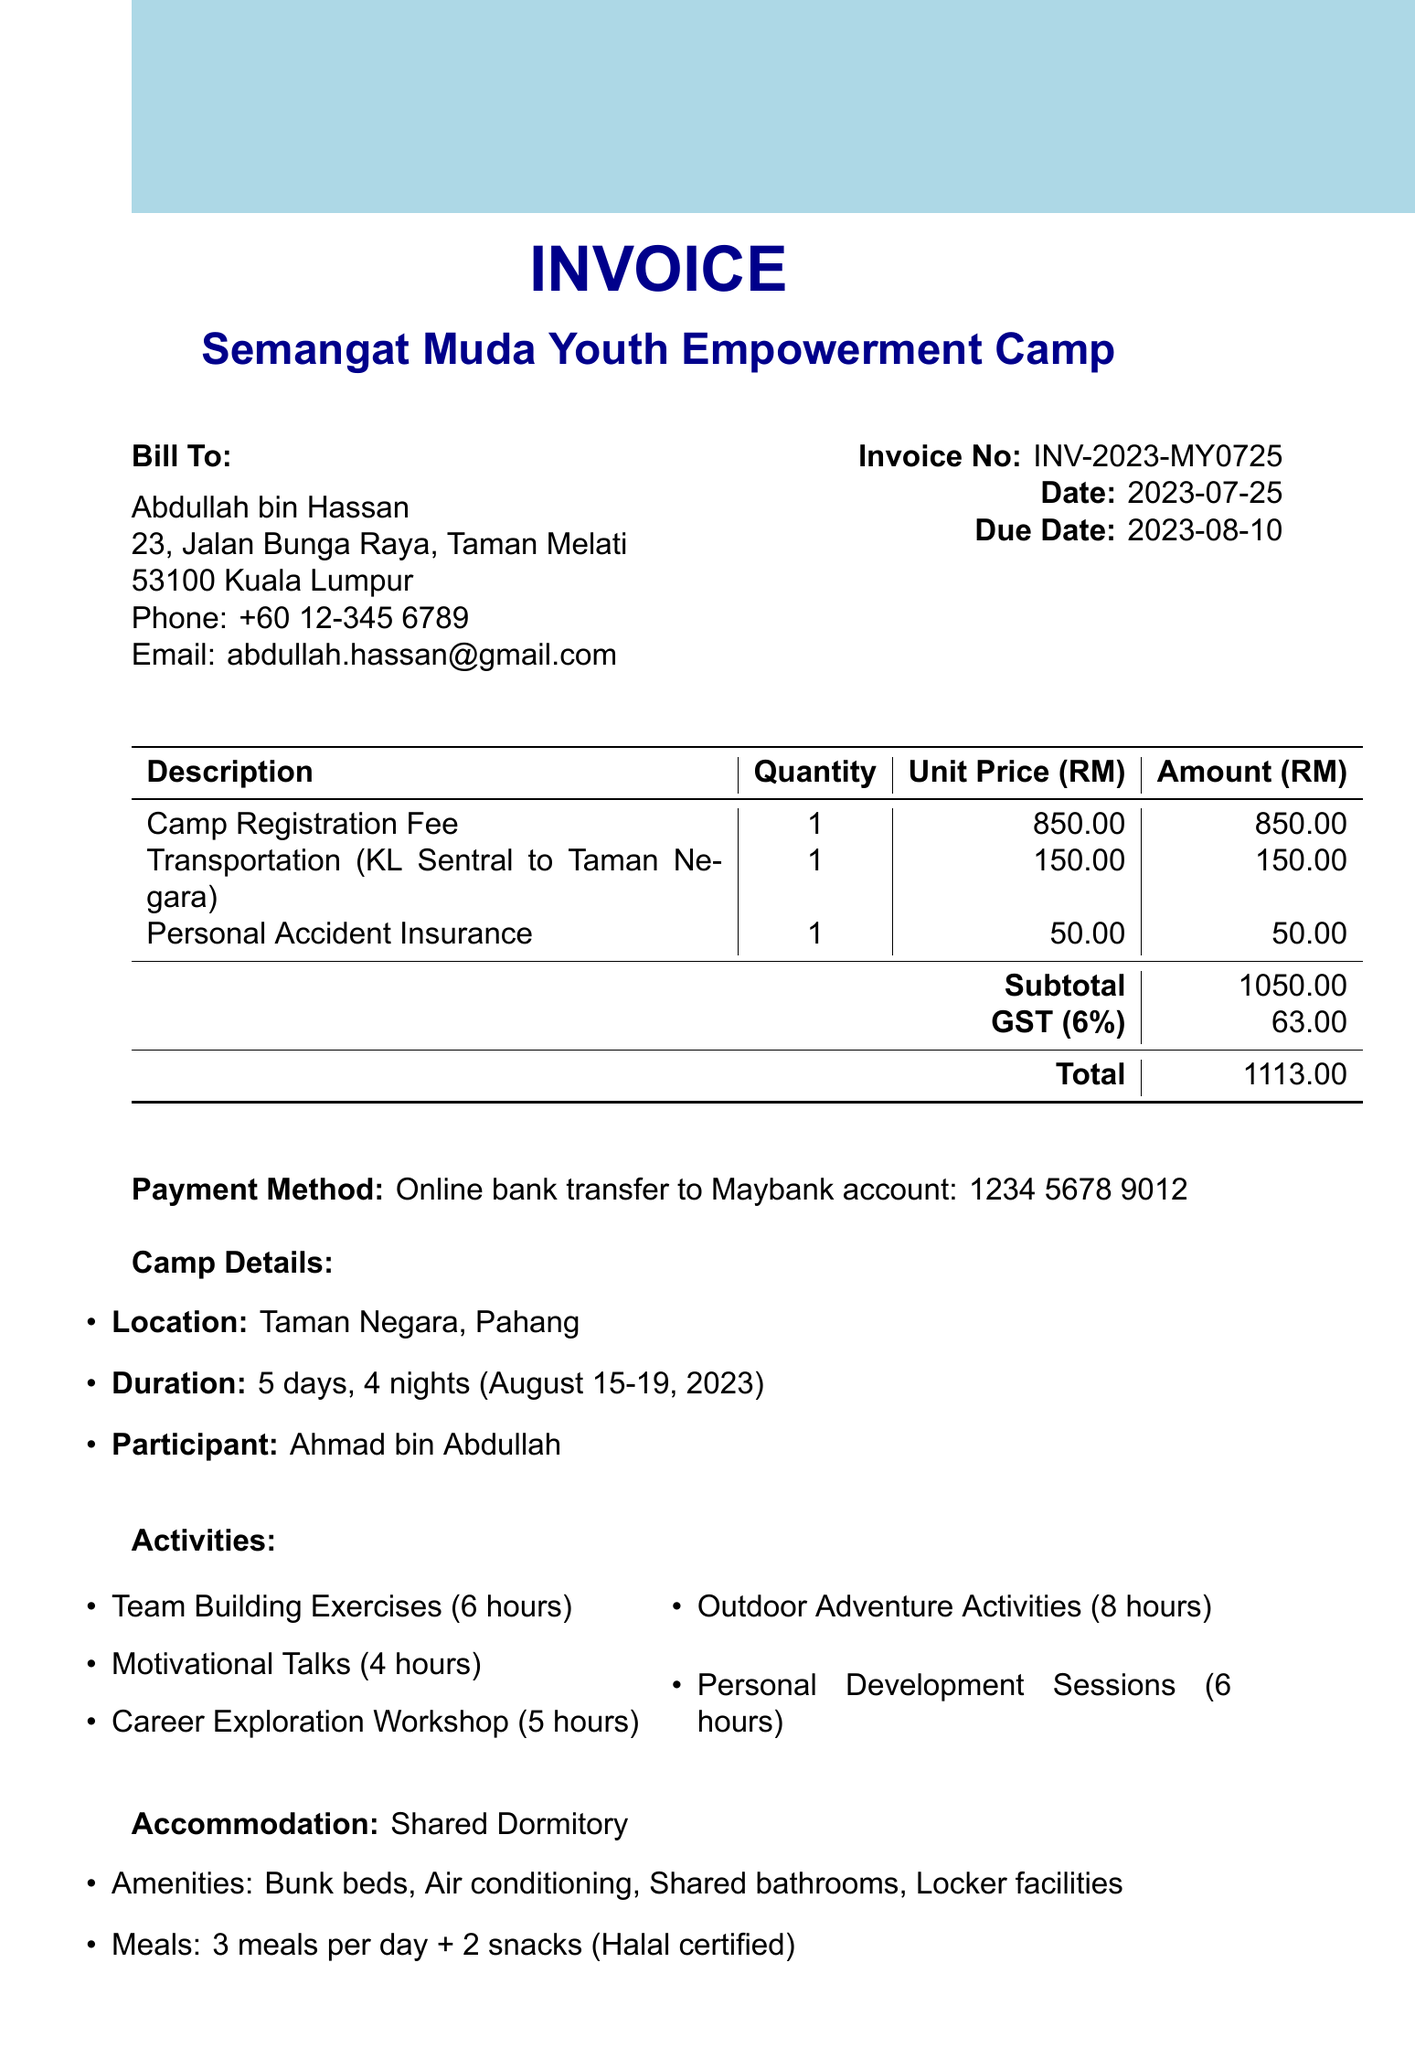what is the camp name? The camp name is clearly stated in the invoice section, which identifies the event.
Answer: Semangat Muda Youth Empowerment Camp what are the camp dates? The camp dates can be found in the camp details section, specifying the duration of the event.
Answer: August 15-19, 2023 who is the participant? The participant's name is listed in the camp details section, indicating who will be attending the camp.
Answer: Ahmad bin Abdullah what is the total amount due? The total amount due is summarized at the end of the invoice, combining all charges and taxes.
Answer: 1113.00 how many hours are allocated for outdoor adventure activities? This information can be found in the activities section, which outlines the duration of each activity.
Answer: 8 hours what type of accommodation is provided? The type of accommodation is explicitly stated in the accommodation section of the document.
Answer: Shared Dormitory what is included in the meals? The meals section specifies what is provided during the camp, including meal frequency and dietary considerations.
Answer: 3 meals per day + 2 snacks (Halal certified) how much is the camp registration fee? The registration fee is itemized in the invoice section, detailing the costs associated with the event.
Answer: 850.00 what is the payment method? The payment method is specifically described towards the end of the invoice, indicating how to settle the amount owed.
Answer: Online bank transfer to Maybank account: 1234 5678 9012 